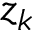<formula> <loc_0><loc_0><loc_500><loc_500>z _ { k }</formula> 